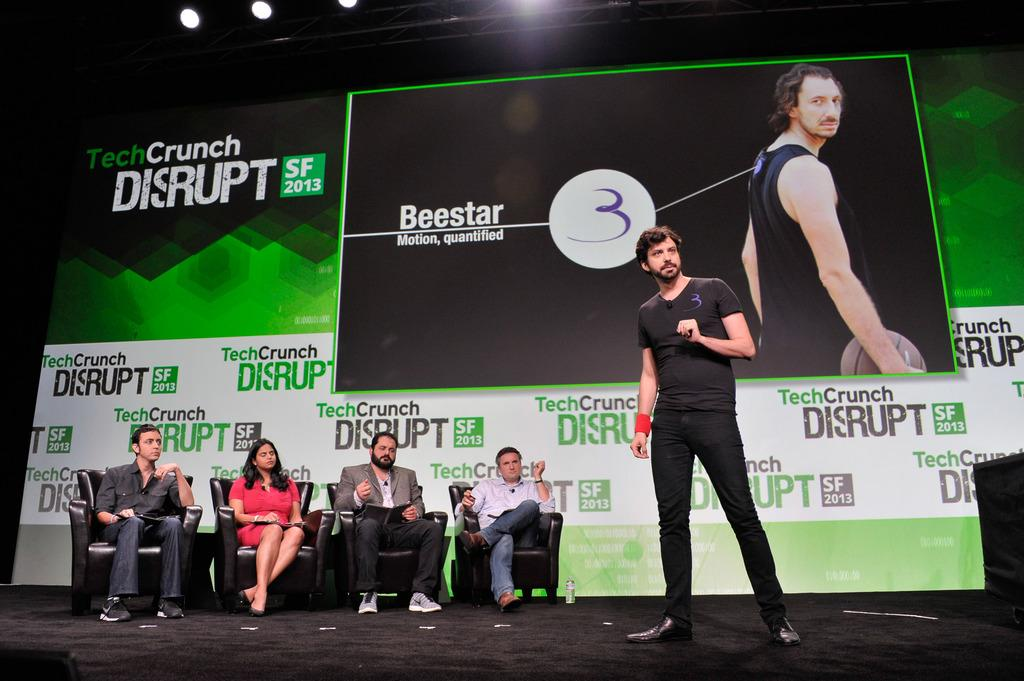How many people are in the image? There are four persons in the image. What are the four persons doing in the image? The four persons are sitting on couches. Is there anyone standing in the image? Yes, there is a person standing in the middle of the image. What is the person standing in front of? The person standing is in front of a flex board. What type of stamp can be seen on the clothes of the persons in the image? There is no stamp visible on the clothes of the persons in the image. How does the self-awareness of the persons in the image affect their behavior? The provided facts do not mention self-awareness or behavior, so it cannot be determined how it affects their behavior. 